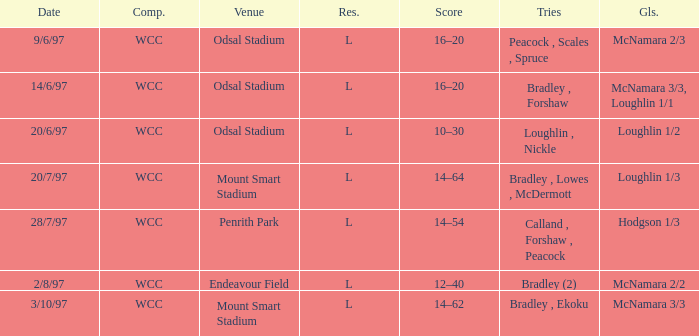What were the goals on 3/10/97? McNamara 3/3. 